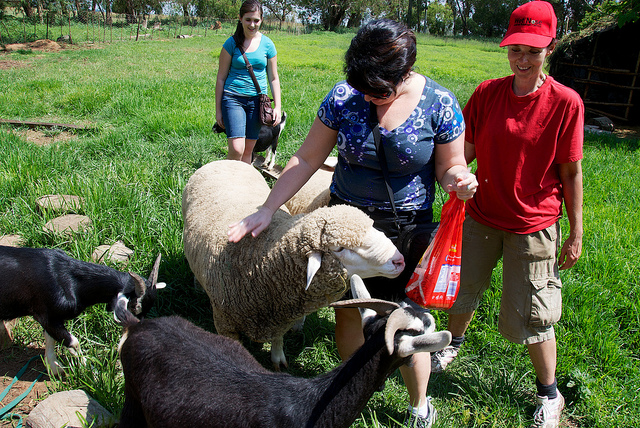Can you describe what the woman in the blue top is doing? The woman in the blue top is petting a sheep with her right hand while holding a red plastic bag in her left hand. She seems to be enjoying the interaction with the animal, possibly feeding or comforting it. 